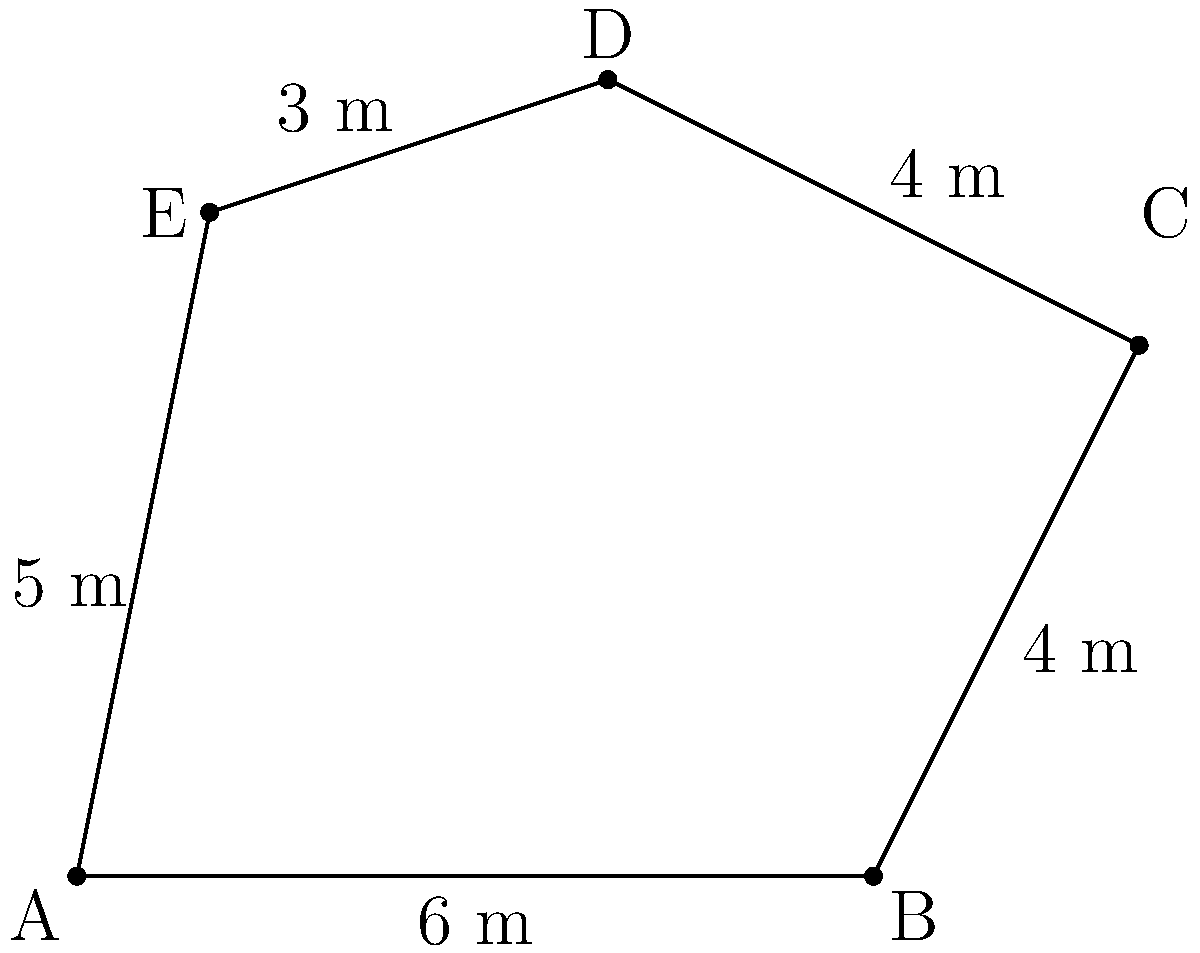Using advanced surveying techniques, you have measured an irregular polygon ABCDE as shown in the figure. The lengths of the sides are: AB = 6 m, BC = 4 m, CD = 4 m, DE = 3 m, and EA = 5 m. Calculate the area of this polygon using the triangulation method, assuming you have measured the following additional distances: AC = 7.21 m, AD = 7.28 m. Round your answer to the nearest 0.01 m². To solve this problem, we'll use the triangulation method and divide the polygon into three triangles: ABC, ACD, and ADE. We'll then calculate the area of each triangle using Heron's formula and sum them up.

1. Heron's formula: $A = \sqrt{s(s-a)(s-b)(s-c)}$, where $s = \frac{a+b+c}{2}$ (semi-perimeter)

2. For triangle ABC:
   $a = 6$ m, $b = 4$ m, $c = 7.21$ m
   $s = \frac{6 + 4 + 7.21}{2} = 8.605$ m
   $A_{ABC} = \sqrt{8.605(8.605-6)(8.605-4)(8.605-7.21)} = 11.98$ m²

3. For triangle ACD:
   $a = 7.21$ m, $b = 4$ m, $c = 7.28$ m
   $s = \frac{7.21 + 4 + 7.28}{2} = 9.245$ m
   $A_{ACD} = \sqrt{9.245(9.245-7.21)(9.245-4)(9.245-7.28)} = 13.98$ m²

4. For triangle ADE:
   $a = 7.28$ m, $b = 3$ m, $c = 5$ m
   $s = \frac{7.28 + 3 + 5}{2} = 7.64$ m
   $A_{ADE} = \sqrt{7.64(7.64-7.28)(7.64-3)(7.64-5)} = 7.49$ m²

5. Total area:
   $A_{total} = A_{ABC} + A_{ACD} + A_{ADE}$
   $A_{total} = 11.98 + 13.98 + 7.49 = 33.45$ m²

Rounding to the nearest 0.01 m², the final answer is 33.45 m².
Answer: 33.45 m² 